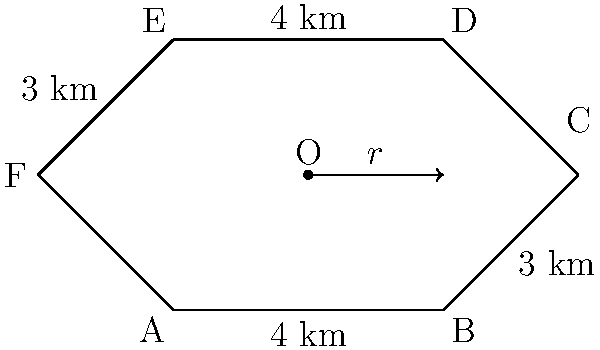As a strategic planner, you're tasked with calculating the area of a new military base with an irregular hexagonal shape. The base's perimeter is formed by six sides with lengths 4 km, 3 km, 2.83 km, 4 km, 3 km, and 2.83 km, as shown in the diagram. If the radius ($r$) of the inscribed circle is 2 km, what is the total area of the base in square kilometers? Consider how this layout might affect the deployment of personnel, particularly in light of gender-integrated units. To solve this problem, we'll use the formula for the area of an irregular hexagon with an inscribed circle:

1) The formula is: $A = rs$, where $A$ is the area, $r$ is the radius of the inscribed circle, and $s$ is the semi-perimeter.

2) Calculate the perimeter:
   $P = 4 + 3 + 2.83 + 4 + 3 + 2.83 = 19.66$ km

3) Calculate the semi-perimeter:
   $s = P/2 = 19.66/2 = 9.83$ km

4) We're given that $r = 2$ km

5) Now we can calculate the area:
   $A = rs = 2 * 9.83 = 19.66$ sq km

This layout provides a balance between defensibility and internal communication. When considering gender-integrated units, this design allows for efficient placement of shared facilities and equal access to strategic points for all personnel, regardless of gender.
Answer: 19.66 sq km 